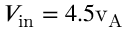Convert formula to latex. <formula><loc_0><loc_0><loc_500><loc_500>V _ { i n } = 4 . 5 v _ { A }</formula> 